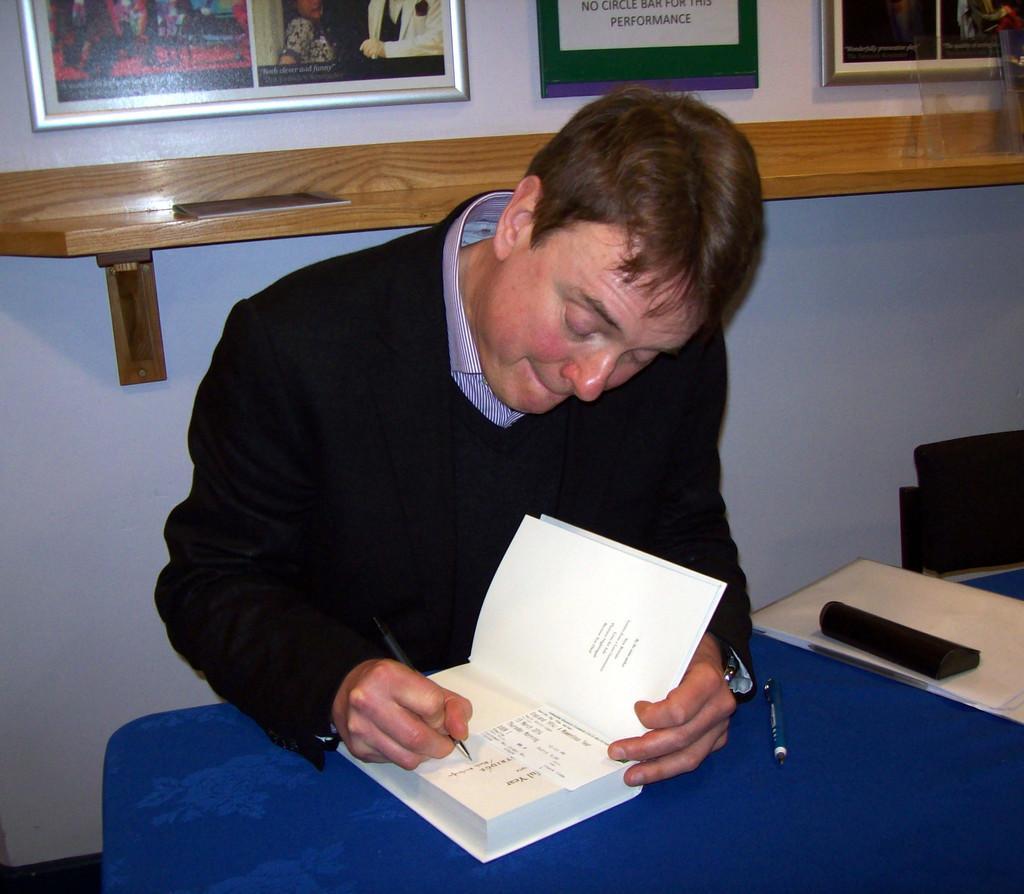Describe this image in one or two sentences. In this image we can see a man sitting on the chair and holding pen in one hand and book on the table in the other hand. On the table we can see open, files and a box. In the background there are wall hangings attached to the wall. 